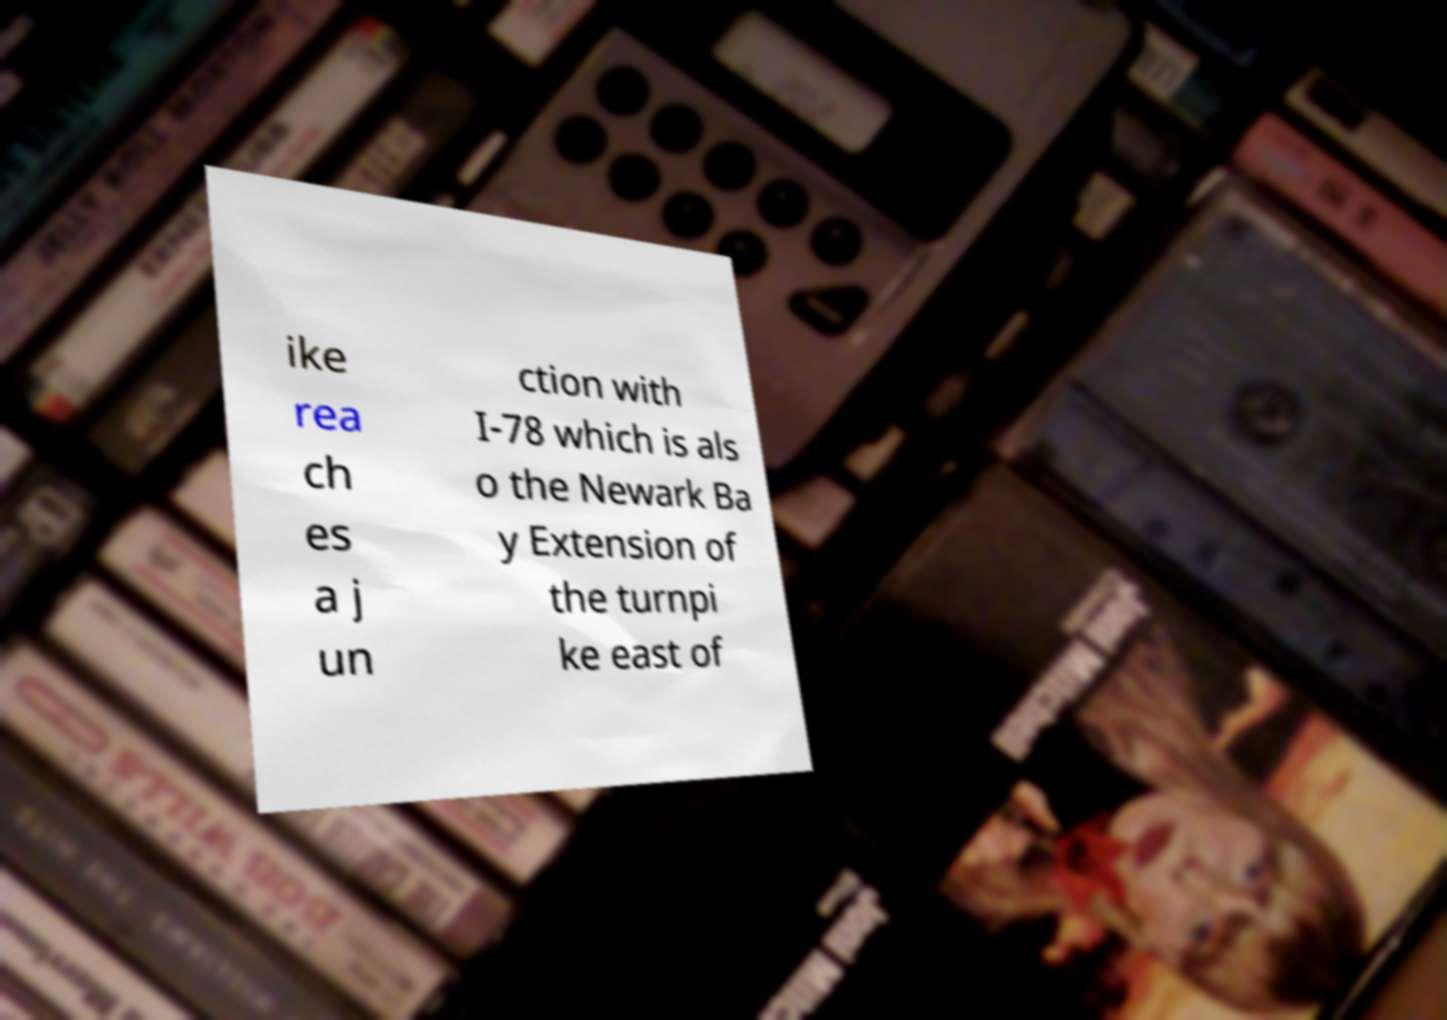Can you accurately transcribe the text from the provided image for me? ike rea ch es a j un ction with I-78 which is als o the Newark Ba y Extension of the turnpi ke east of 